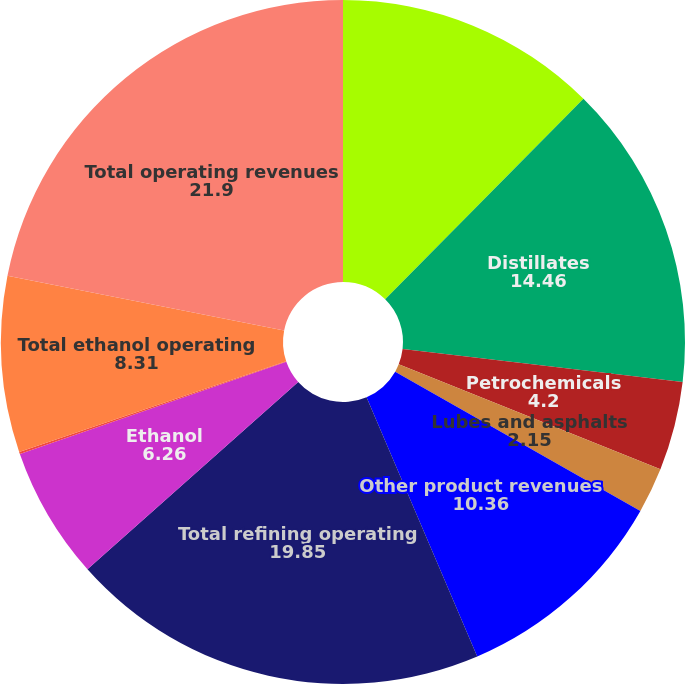<chart> <loc_0><loc_0><loc_500><loc_500><pie_chart><fcel>Gasolines and blendstocks<fcel>Distillates<fcel>Petrochemicals<fcel>Lubes and asphalts<fcel>Other product revenues<fcel>Total refining operating<fcel>Ethanol<fcel>Distillers grains<fcel>Total ethanol operating<fcel>Total operating revenues<nl><fcel>12.41%<fcel>14.46%<fcel>4.2%<fcel>2.15%<fcel>10.36%<fcel>19.85%<fcel>6.26%<fcel>0.1%<fcel>8.31%<fcel>21.9%<nl></chart> 